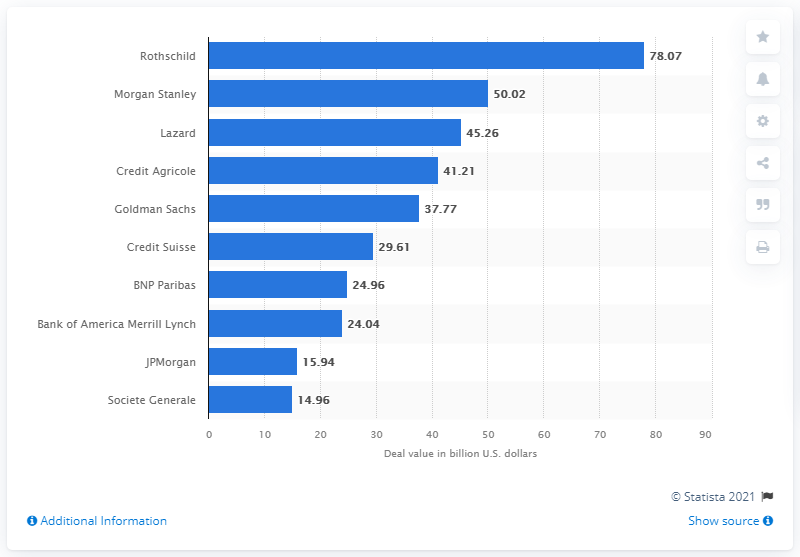Specify some key components in this picture. In 2016, the deal value of Rothschild amounted to 78.07. In 2016, Rothschild was the leading advisor to mergers and acquisitions deals in France. 